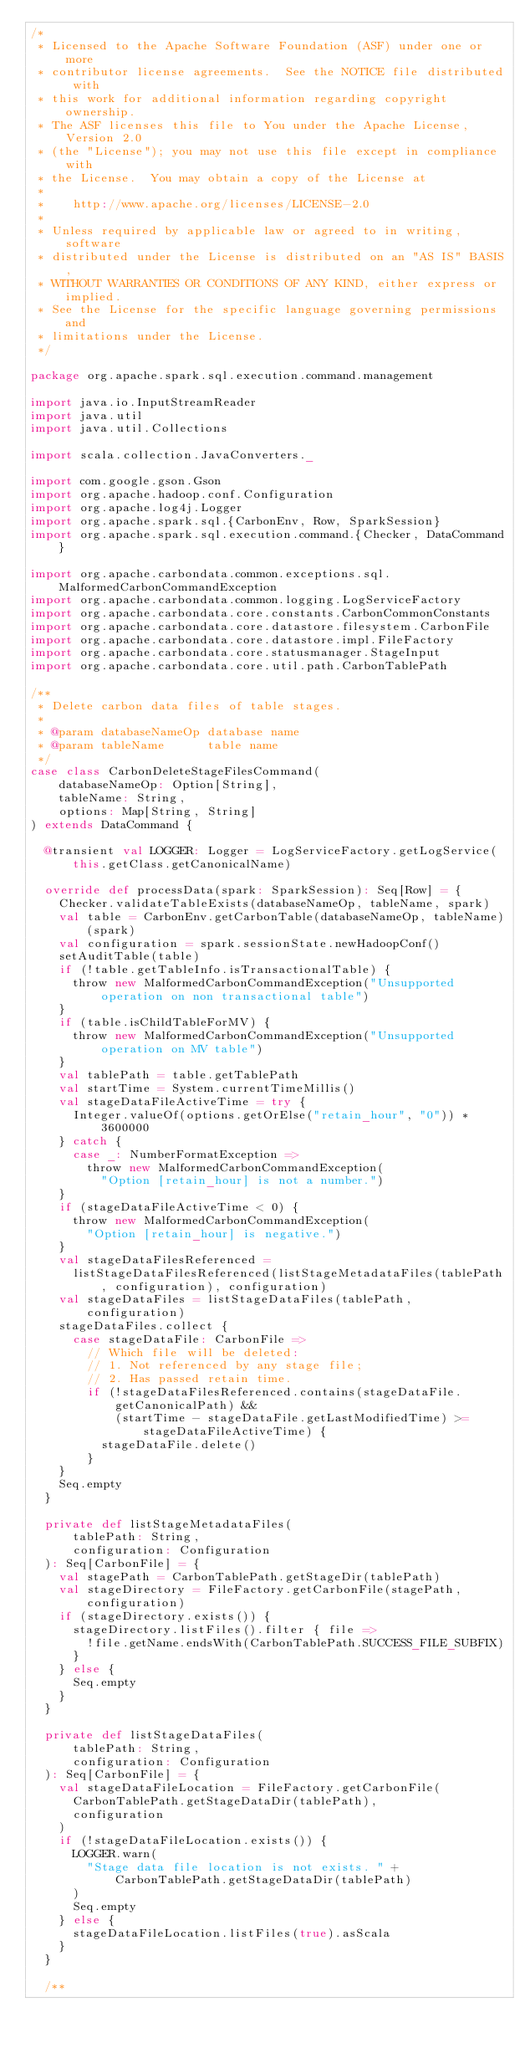Convert code to text. <code><loc_0><loc_0><loc_500><loc_500><_Scala_>/*
 * Licensed to the Apache Software Foundation (ASF) under one or more
 * contributor license agreements.  See the NOTICE file distributed with
 * this work for additional information regarding copyright ownership.
 * The ASF licenses this file to You under the Apache License, Version 2.0
 * (the "License"); you may not use this file except in compliance with
 * the License.  You may obtain a copy of the License at
 *
 *    http://www.apache.org/licenses/LICENSE-2.0
 *
 * Unless required by applicable law or agreed to in writing, software
 * distributed under the License is distributed on an "AS IS" BASIS,
 * WITHOUT WARRANTIES OR CONDITIONS OF ANY KIND, either express or implied.
 * See the License for the specific language governing permissions and
 * limitations under the License.
 */

package org.apache.spark.sql.execution.command.management

import java.io.InputStreamReader
import java.util
import java.util.Collections

import scala.collection.JavaConverters._

import com.google.gson.Gson
import org.apache.hadoop.conf.Configuration
import org.apache.log4j.Logger
import org.apache.spark.sql.{CarbonEnv, Row, SparkSession}
import org.apache.spark.sql.execution.command.{Checker, DataCommand}

import org.apache.carbondata.common.exceptions.sql.MalformedCarbonCommandException
import org.apache.carbondata.common.logging.LogServiceFactory
import org.apache.carbondata.core.constants.CarbonCommonConstants
import org.apache.carbondata.core.datastore.filesystem.CarbonFile
import org.apache.carbondata.core.datastore.impl.FileFactory
import org.apache.carbondata.core.statusmanager.StageInput
import org.apache.carbondata.core.util.path.CarbonTablePath

/**
 * Delete carbon data files of table stages.
 *
 * @param databaseNameOp database name
 * @param tableName      table name
 */
case class CarbonDeleteStageFilesCommand(
    databaseNameOp: Option[String],
    tableName: String,
    options: Map[String, String]
) extends DataCommand {

  @transient val LOGGER: Logger = LogServiceFactory.getLogService(this.getClass.getCanonicalName)

  override def processData(spark: SparkSession): Seq[Row] = {
    Checker.validateTableExists(databaseNameOp, tableName, spark)
    val table = CarbonEnv.getCarbonTable(databaseNameOp, tableName)(spark)
    val configuration = spark.sessionState.newHadoopConf()
    setAuditTable(table)
    if (!table.getTableInfo.isTransactionalTable) {
      throw new MalformedCarbonCommandException("Unsupported operation on non transactional table")
    }
    if (table.isChildTableForMV) {
      throw new MalformedCarbonCommandException("Unsupported operation on MV table")
    }
    val tablePath = table.getTablePath
    val startTime = System.currentTimeMillis()
    val stageDataFileActiveTime = try {
      Integer.valueOf(options.getOrElse("retain_hour", "0")) * 3600000
    } catch {
      case _: NumberFormatException =>
        throw new MalformedCarbonCommandException(
          "Option [retain_hour] is not a number.")
    }
    if (stageDataFileActiveTime < 0) {
      throw new MalformedCarbonCommandException(
        "Option [retain_hour] is negative.")
    }
    val stageDataFilesReferenced =
      listStageDataFilesReferenced(listStageMetadataFiles(tablePath, configuration), configuration)
    val stageDataFiles = listStageDataFiles(tablePath, configuration)
    stageDataFiles.collect {
      case stageDataFile: CarbonFile =>
        // Which file will be deleted:
        // 1. Not referenced by any stage file;
        // 2. Has passed retain time.
        if (!stageDataFilesReferenced.contains(stageDataFile.getCanonicalPath) &&
            (startTime - stageDataFile.getLastModifiedTime) >= stageDataFileActiveTime) {
          stageDataFile.delete()
        }
    }
    Seq.empty
  }

  private def listStageMetadataFiles(
      tablePath: String,
      configuration: Configuration
  ): Seq[CarbonFile] = {
    val stagePath = CarbonTablePath.getStageDir(tablePath)
    val stageDirectory = FileFactory.getCarbonFile(stagePath, configuration)
    if (stageDirectory.exists()) {
      stageDirectory.listFiles().filter { file =>
        !file.getName.endsWith(CarbonTablePath.SUCCESS_FILE_SUBFIX)
      }
    } else {
      Seq.empty
    }
  }

  private def listStageDataFiles(
      tablePath: String,
      configuration: Configuration
  ): Seq[CarbonFile] = {
    val stageDataFileLocation = FileFactory.getCarbonFile(
      CarbonTablePath.getStageDataDir(tablePath),
      configuration
    )
    if (!stageDataFileLocation.exists()) {
      LOGGER.warn(
        "Stage data file location is not exists. " + CarbonTablePath.getStageDataDir(tablePath)
      )
      Seq.empty
    } else {
      stageDataFileLocation.listFiles(true).asScala
    }
  }

  /**</code> 